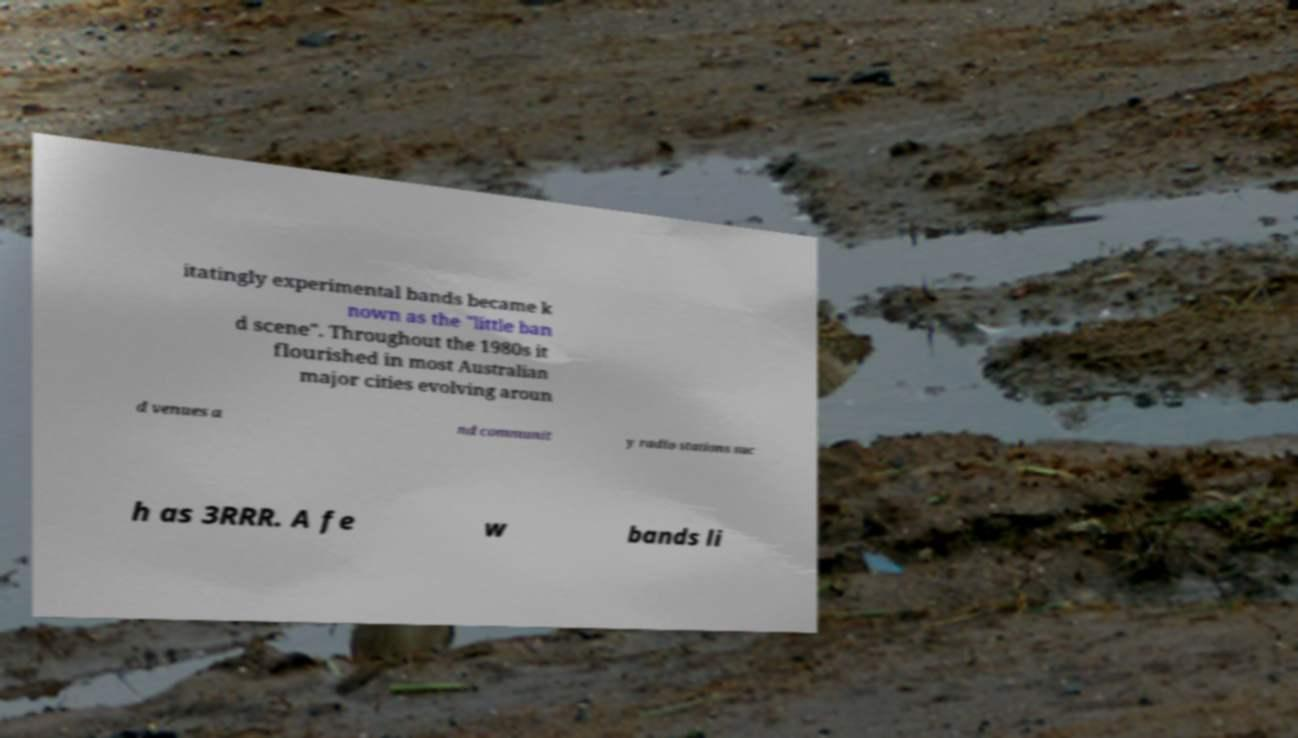Please read and relay the text visible in this image. What does it say? itatingly experimental bands became k nown as the "little ban d scene". Throughout the 1980s it flourished in most Australian major cities evolving aroun d venues a nd communit y radio stations suc h as 3RRR. A fe w bands li 